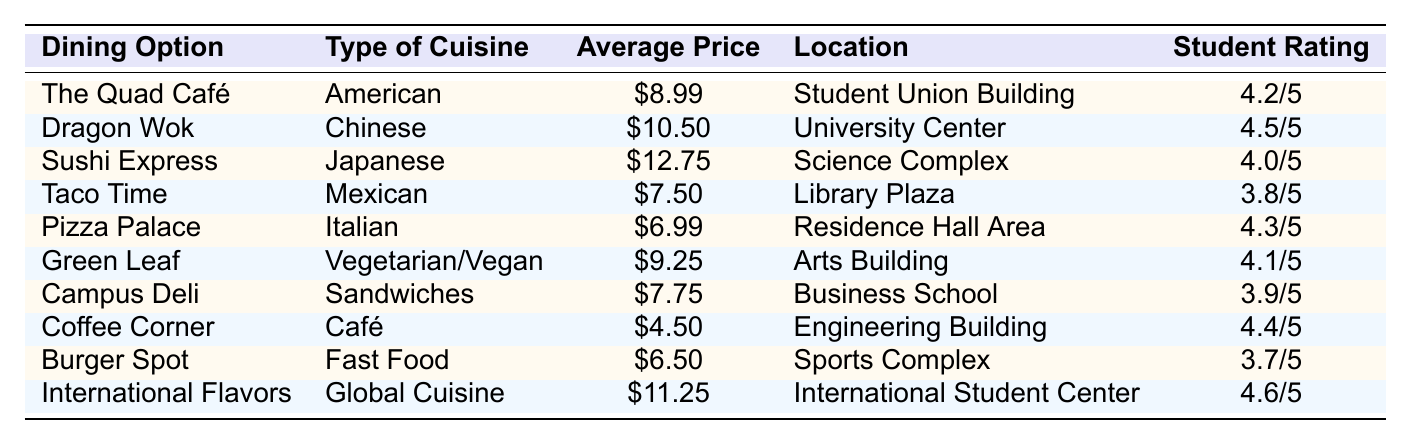What is the average price of dining options listed in the table? To find the average price, sum the prices of all ten dining options: $8.99 + $10.50 + $12.75 + $7.50 + $6.99 + $9.25 + $7.75 + $4.50 + $6.50 + $11.25 = $85.54. Then divide by the number of options (10): $85.54 / 10 = $8.55.
Answer: $8.55 Which dining option has the highest student rating? The student ratings for all options are compared: 4.2, 4.5, 4.0, 3.8, 4.3, 4.1, 3.9, 4.4, 3.7, and 4.6. The highest value is 4.6 for "International Flavors."
Answer: International Flavors Is "Coffee Corner" more expensive than "Taco Time"? The average price of "Coffee Corner" is $4.50 and "Taco Time" is $7.50. Since $4.50 is less than $7.50, the statement is false.
Answer: No What percentage of dining options have a price greater than $10? There are 10 options total. The options over $10 are "Dragon Wok" at $10.50, "Sushi Express" at $12.75, and "International Flavors" at $11.25, totaling 3 options. To find the percentage: (3 / 10) * 100 = 30%.
Answer: 30% What is the location of the dining option with the lowest price? The lowest price is $4.50 for "Coffee Corner." The location of "Coffee Corner" is the Engineering Building.
Answer: Engineering Building If we were to rank all dining options by price, which one would be third? Listing the prices in ascending order: $4.50 (Coffee Corner), $6.50 (Burger Spot), $6.99 (Pizza Palace), $7.50 (Taco Time), $7.75 (Campus Deli), $8.99 (The Quad Café), $9.25 (Green Leaf), $10.50 (Dragon Wok), $11.25 (International Flavors), $12.75 (Sushi Express). The third price is $6.99 for "Pizza Palace."
Answer: Pizza Palace Do any dining options offer a vegetarian or vegan cuisine? Looking through the list, "Green Leaf" is the only vegetarian/vegan option. Therefore, the answer is yes.
Answer: Yes What is the average rating of all dining options? The ratings are 4.2, 4.5, 4.0, 3.8, 4.3, 4.1, 3.9, 4.4, 3.7, and 4.6. The sum of these ratings is 43.5. Then, divide by the total number of options (10): 43.5 / 10 = 4.35.
Answer: 4.35 Which type of cuisine has the most dining options listed? By visually checking, we see that American, Chinese, Japanese, Mexican, Italian, Vegetarian/Vegan, Sandwiches, Café, Fast Food, and Global Cuisine all represent different cuisines. Each type appears only once, therefore, no type has more than one option listed.
Answer: None What is the difference in ratings between the highest and lowest-rated dining options? The highest rating is 4.6 (International Flavors) and the lowest is 3.7 (Burger Spot). The difference is calculated as 4.6 - 3.7 = 0.9.
Answer: 0.9 